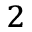<formula> <loc_0><loc_0><loc_500><loc_500>^ { 2 }</formula> 